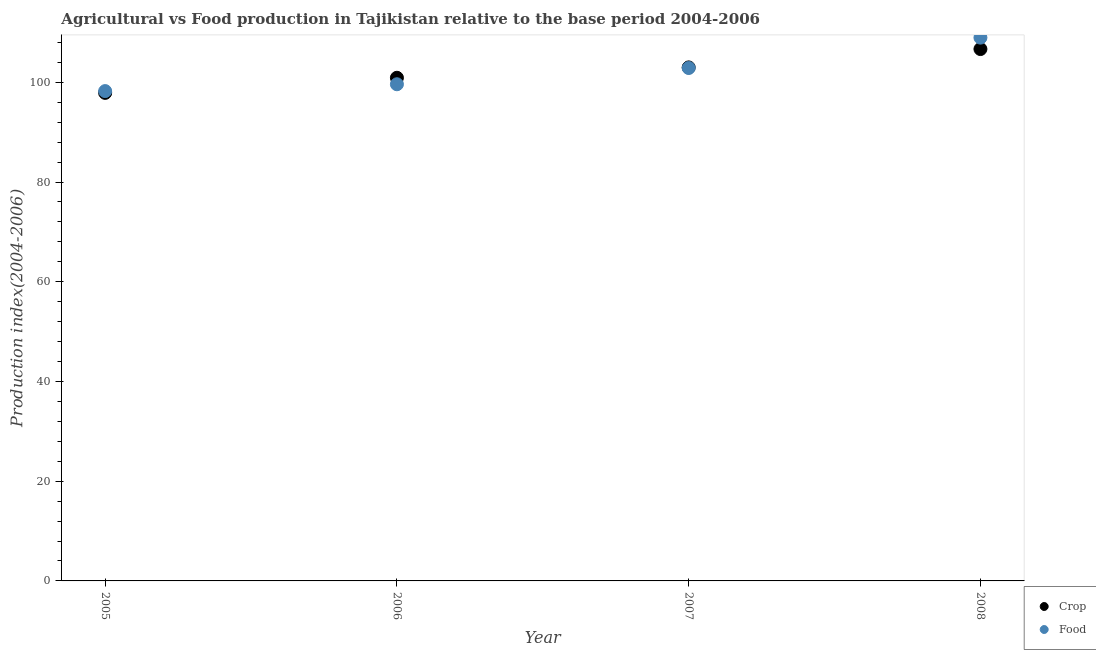How many different coloured dotlines are there?
Offer a very short reply. 2. What is the crop production index in 2006?
Your response must be concise. 100.91. Across all years, what is the maximum crop production index?
Provide a short and direct response. 106.67. Across all years, what is the minimum food production index?
Provide a succinct answer. 98.24. What is the total crop production index in the graph?
Give a very brief answer. 408.45. What is the difference between the food production index in 2006 and that in 2008?
Your response must be concise. -9.35. What is the difference between the crop production index in 2007 and the food production index in 2006?
Ensure brevity in your answer.  3.38. What is the average food production index per year?
Make the answer very short. 102.42. In the year 2008, what is the difference between the crop production index and food production index?
Your answer should be compact. -2.29. In how many years, is the food production index greater than 104?
Your answer should be compact. 1. What is the ratio of the crop production index in 2006 to that in 2008?
Give a very brief answer. 0.95. Is the food production index in 2005 less than that in 2006?
Provide a succinct answer. Yes. Is the difference between the food production index in 2006 and 2007 greater than the difference between the crop production index in 2006 and 2007?
Keep it short and to the point. No. What is the difference between the highest and the second highest crop production index?
Your answer should be very brief. 3.68. What is the difference between the highest and the lowest crop production index?
Ensure brevity in your answer.  8.79. In how many years, is the food production index greater than the average food production index taken over all years?
Ensure brevity in your answer.  2. Does the crop production index monotonically increase over the years?
Your answer should be compact. Yes. Is the crop production index strictly greater than the food production index over the years?
Your answer should be compact. No. How many years are there in the graph?
Give a very brief answer. 4. What is the difference between two consecutive major ticks on the Y-axis?
Provide a succinct answer. 20. Are the values on the major ticks of Y-axis written in scientific E-notation?
Keep it short and to the point. No. Does the graph contain any zero values?
Provide a short and direct response. No. Does the graph contain grids?
Your answer should be very brief. No. How many legend labels are there?
Ensure brevity in your answer.  2. What is the title of the graph?
Offer a terse response. Agricultural vs Food production in Tajikistan relative to the base period 2004-2006. Does "Merchandise exports" appear as one of the legend labels in the graph?
Make the answer very short. No. What is the label or title of the X-axis?
Offer a very short reply. Year. What is the label or title of the Y-axis?
Provide a short and direct response. Production index(2004-2006). What is the Production index(2004-2006) of Crop in 2005?
Make the answer very short. 97.88. What is the Production index(2004-2006) of Food in 2005?
Ensure brevity in your answer.  98.24. What is the Production index(2004-2006) of Crop in 2006?
Provide a succinct answer. 100.91. What is the Production index(2004-2006) of Food in 2006?
Your answer should be compact. 99.61. What is the Production index(2004-2006) of Crop in 2007?
Provide a short and direct response. 102.99. What is the Production index(2004-2006) in Food in 2007?
Your answer should be compact. 102.87. What is the Production index(2004-2006) of Crop in 2008?
Make the answer very short. 106.67. What is the Production index(2004-2006) in Food in 2008?
Make the answer very short. 108.96. Across all years, what is the maximum Production index(2004-2006) in Crop?
Offer a terse response. 106.67. Across all years, what is the maximum Production index(2004-2006) of Food?
Your answer should be compact. 108.96. Across all years, what is the minimum Production index(2004-2006) in Crop?
Keep it short and to the point. 97.88. Across all years, what is the minimum Production index(2004-2006) of Food?
Provide a succinct answer. 98.24. What is the total Production index(2004-2006) in Crop in the graph?
Provide a succinct answer. 408.45. What is the total Production index(2004-2006) in Food in the graph?
Offer a terse response. 409.68. What is the difference between the Production index(2004-2006) of Crop in 2005 and that in 2006?
Ensure brevity in your answer.  -3.03. What is the difference between the Production index(2004-2006) of Food in 2005 and that in 2006?
Your response must be concise. -1.37. What is the difference between the Production index(2004-2006) in Crop in 2005 and that in 2007?
Provide a short and direct response. -5.11. What is the difference between the Production index(2004-2006) of Food in 2005 and that in 2007?
Ensure brevity in your answer.  -4.63. What is the difference between the Production index(2004-2006) in Crop in 2005 and that in 2008?
Provide a short and direct response. -8.79. What is the difference between the Production index(2004-2006) of Food in 2005 and that in 2008?
Provide a short and direct response. -10.72. What is the difference between the Production index(2004-2006) in Crop in 2006 and that in 2007?
Ensure brevity in your answer.  -2.08. What is the difference between the Production index(2004-2006) of Food in 2006 and that in 2007?
Keep it short and to the point. -3.26. What is the difference between the Production index(2004-2006) of Crop in 2006 and that in 2008?
Keep it short and to the point. -5.76. What is the difference between the Production index(2004-2006) of Food in 2006 and that in 2008?
Ensure brevity in your answer.  -9.35. What is the difference between the Production index(2004-2006) in Crop in 2007 and that in 2008?
Keep it short and to the point. -3.68. What is the difference between the Production index(2004-2006) of Food in 2007 and that in 2008?
Your answer should be compact. -6.09. What is the difference between the Production index(2004-2006) in Crop in 2005 and the Production index(2004-2006) in Food in 2006?
Your answer should be very brief. -1.73. What is the difference between the Production index(2004-2006) in Crop in 2005 and the Production index(2004-2006) in Food in 2007?
Your answer should be compact. -4.99. What is the difference between the Production index(2004-2006) of Crop in 2005 and the Production index(2004-2006) of Food in 2008?
Make the answer very short. -11.08. What is the difference between the Production index(2004-2006) of Crop in 2006 and the Production index(2004-2006) of Food in 2007?
Your answer should be compact. -1.96. What is the difference between the Production index(2004-2006) of Crop in 2006 and the Production index(2004-2006) of Food in 2008?
Provide a short and direct response. -8.05. What is the difference between the Production index(2004-2006) of Crop in 2007 and the Production index(2004-2006) of Food in 2008?
Give a very brief answer. -5.97. What is the average Production index(2004-2006) of Crop per year?
Provide a short and direct response. 102.11. What is the average Production index(2004-2006) in Food per year?
Offer a very short reply. 102.42. In the year 2005, what is the difference between the Production index(2004-2006) of Crop and Production index(2004-2006) of Food?
Give a very brief answer. -0.36. In the year 2006, what is the difference between the Production index(2004-2006) of Crop and Production index(2004-2006) of Food?
Your answer should be very brief. 1.3. In the year 2007, what is the difference between the Production index(2004-2006) of Crop and Production index(2004-2006) of Food?
Your answer should be very brief. 0.12. In the year 2008, what is the difference between the Production index(2004-2006) in Crop and Production index(2004-2006) in Food?
Your answer should be very brief. -2.29. What is the ratio of the Production index(2004-2006) in Food in 2005 to that in 2006?
Make the answer very short. 0.99. What is the ratio of the Production index(2004-2006) in Crop in 2005 to that in 2007?
Keep it short and to the point. 0.95. What is the ratio of the Production index(2004-2006) in Food in 2005 to that in 2007?
Provide a succinct answer. 0.95. What is the ratio of the Production index(2004-2006) of Crop in 2005 to that in 2008?
Ensure brevity in your answer.  0.92. What is the ratio of the Production index(2004-2006) of Food in 2005 to that in 2008?
Keep it short and to the point. 0.9. What is the ratio of the Production index(2004-2006) of Crop in 2006 to that in 2007?
Offer a terse response. 0.98. What is the ratio of the Production index(2004-2006) of Food in 2006 to that in 2007?
Make the answer very short. 0.97. What is the ratio of the Production index(2004-2006) of Crop in 2006 to that in 2008?
Provide a succinct answer. 0.95. What is the ratio of the Production index(2004-2006) in Food in 2006 to that in 2008?
Ensure brevity in your answer.  0.91. What is the ratio of the Production index(2004-2006) of Crop in 2007 to that in 2008?
Offer a terse response. 0.97. What is the ratio of the Production index(2004-2006) of Food in 2007 to that in 2008?
Keep it short and to the point. 0.94. What is the difference between the highest and the second highest Production index(2004-2006) of Crop?
Your answer should be compact. 3.68. What is the difference between the highest and the second highest Production index(2004-2006) of Food?
Offer a terse response. 6.09. What is the difference between the highest and the lowest Production index(2004-2006) in Crop?
Keep it short and to the point. 8.79. What is the difference between the highest and the lowest Production index(2004-2006) in Food?
Ensure brevity in your answer.  10.72. 